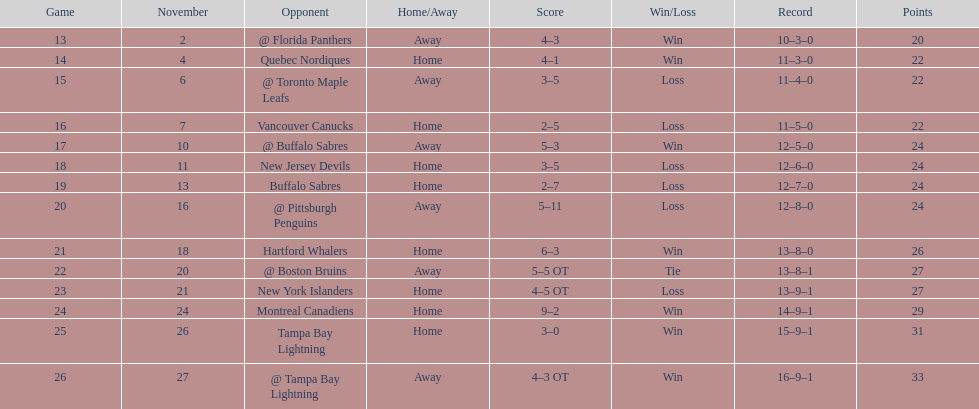What other team had the closest amount of wins? New York Islanders. 